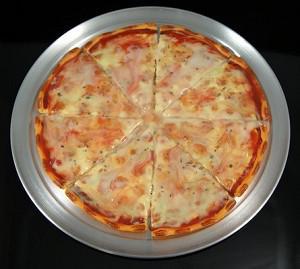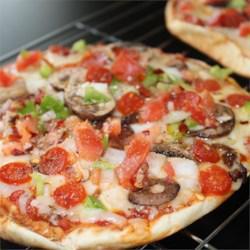The first image is the image on the left, the second image is the image on the right. Assess this claim about the two images: "The left image features one sliced pizza on a round silver tray, with no slices missing and with similar toppings across the whole pizza.". Correct or not? Answer yes or no. Yes. 